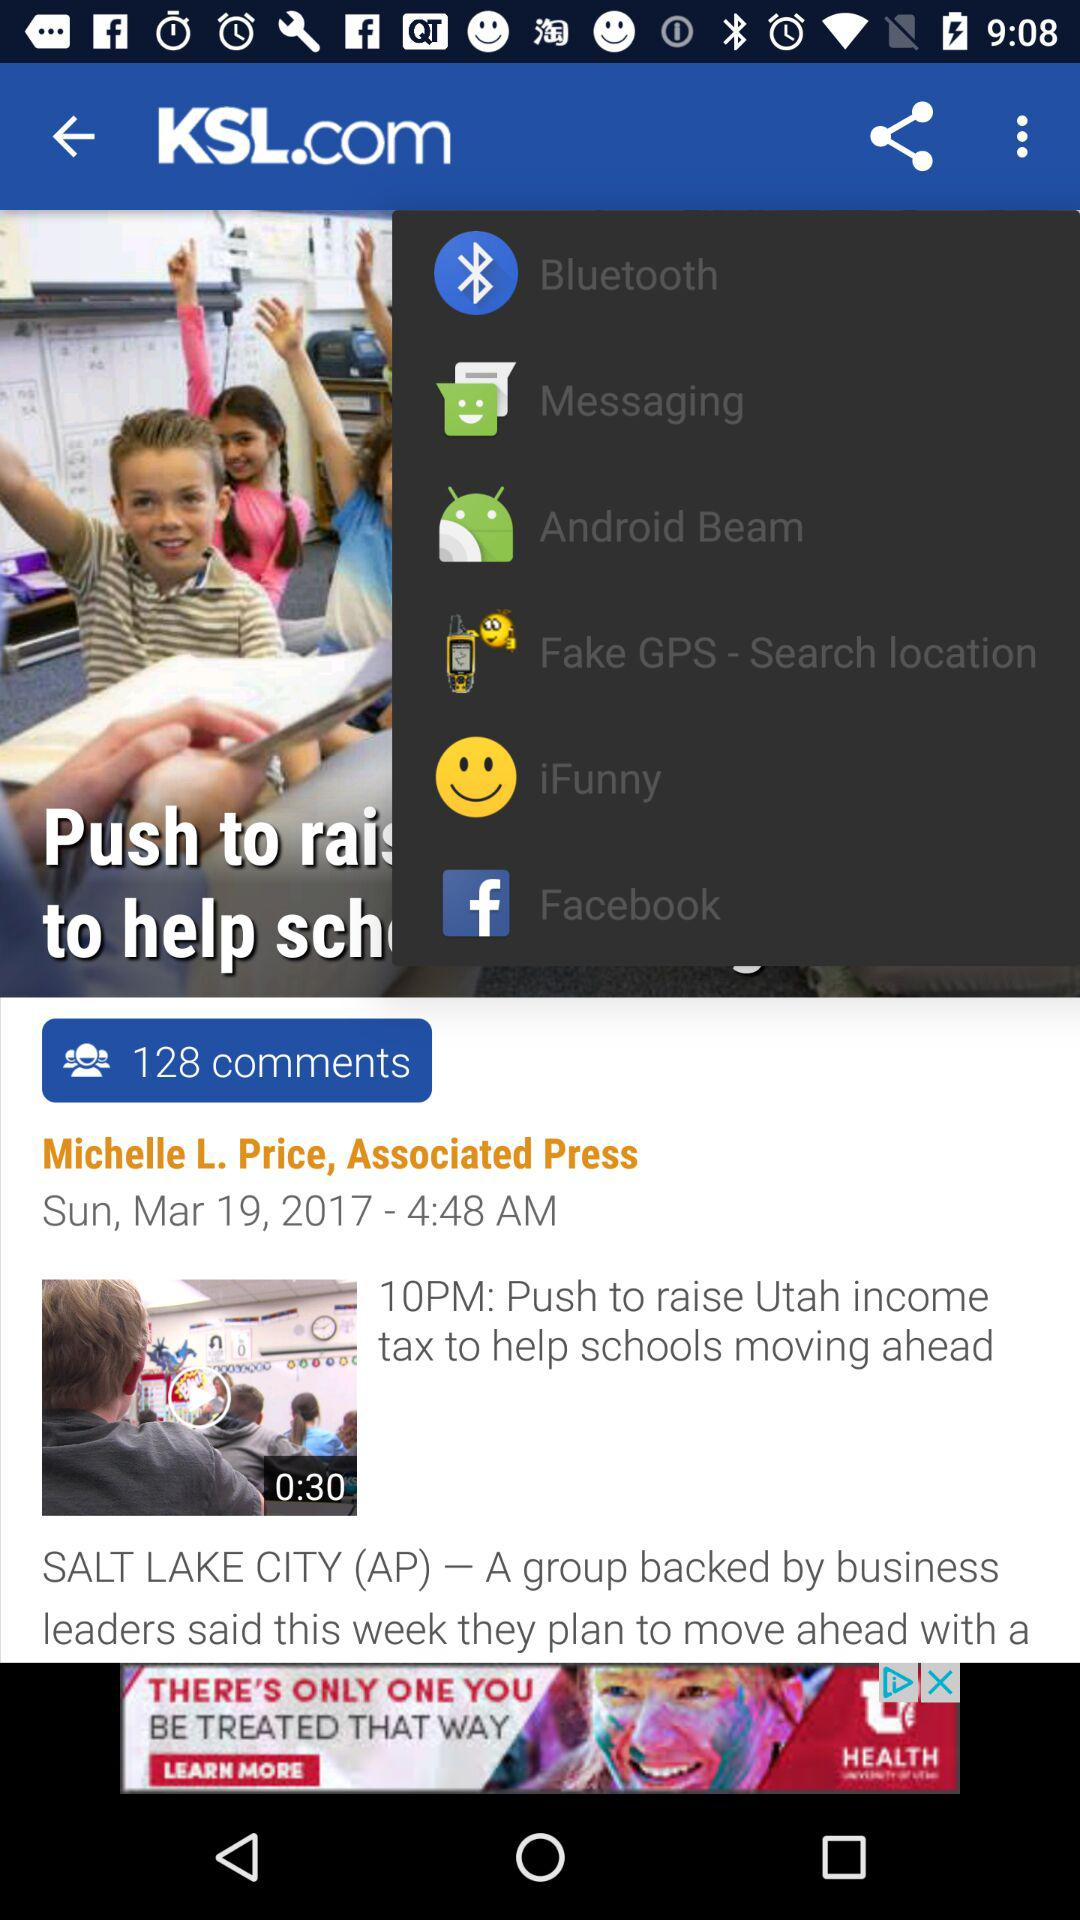How many comments are there? There are 128 comments. 